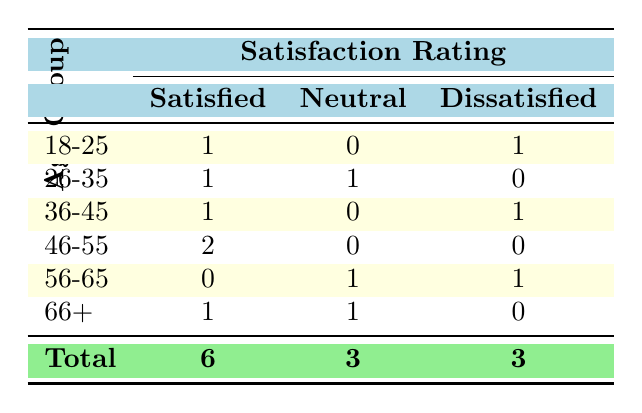What is the total number of respondents that were "Satisfied"? By looking at the table, we find the numbers under the "Satisfied" column: 1 (18-25) + 1 (26-35) + 1 (36-45) + 2 (46-55) + 0 (56-65) + 1 (66+) = 6. Thus, the total number of respondents that were "Satisfied" is 6.
Answer: 6 How many respondents in the age group 36-45 were "Dissatisfied"? The entry for the age group 36-45 shows that there is 1 response indicating "Dissatisfied." We can confirm this by looking directly at the row for age group 36-45 under the "Dissatisfied" column.
Answer: 1 What is the total number of respondents in the age group 56-65? In the table, the age group 56-65 has 1 "Neutral" and 1 "Dissatisfied" response, so the total is 1 + 1 = 2 respondents.
Answer: 2 Are there more respondents in the age group 46-55 than in the age group 18-25? The age group 46-55 has 2 respondents who are "Satisfied" and 0 who are "Neutral" or "Dissatisfied," totaling 2. The age group 18-25, conversely, has 1 who is "Satisfied" and 1 who is "Dissatisfied," totaling 2. Therefore, they are equal, so the answer is "No."
Answer: No What is the average number of "Neutral" responses across all age groups? We add the counts of "Neutral" responses from all age groups: 0 (18-25) + 1 (26-35) + 0 (36-45) + 0 (46-55) + 1 (56-65) + 1 (66+) = 3. There are 6 age groups, so the average is 3 / 6 = 0.5.
Answer: 0.5 Which age group had the highest number of "Dissatisfied" responses? The only age groups with "Dissatisfied" responses are 18-25 (1), 36-45 (1), 56-65 (1), and the others have 0. Since they are all tied with 1 response, none can be said to have the highest; therefore, all these groups are equal.
Answer: None How many total respondents reported either "Neutral" or "Dissatisfied"? Counting the entries under both "Neutral" and "Dissatisfied": Neutral (3) + Dissatisfied (3) gives a total of 3 + 3 = 6.
Answer: 6 In the 66+ age group, how many people responded as "Neutral"? The 66+ age group shows there was 1 response labeled "Neutral." This can be confirmed by checking the corresponding entry.
Answer: 1 What proportion of respondents were "Dissatisfied" out of the total? The total number of respondents is 12 (6 "Satisfied" + 3 "Neutral" + 3 "Dissatisfied"). The "Dissatisfied" count is 3, so the proportion is 3 out of 12, which gives us 3/12 = 0.25 or 25%.
Answer: 25% 